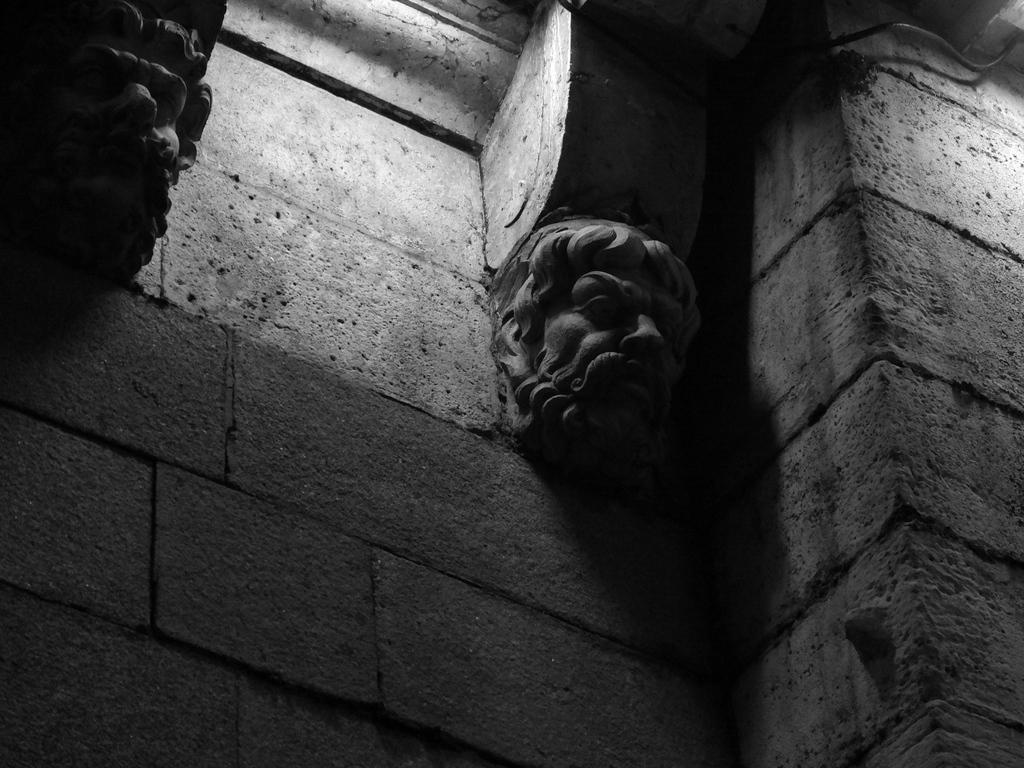What type of art is present in the image? There are sculptures in the image. What type of structure can be seen in the image? There is a cement wall in the image. Where might the image have been taken? The image may have been taken in a building. What type of prose is being recited by the sculpture in the image? There is no indication in the image that the sculpture is reciting any prose, as sculptures are not capable of speech or recitation. 